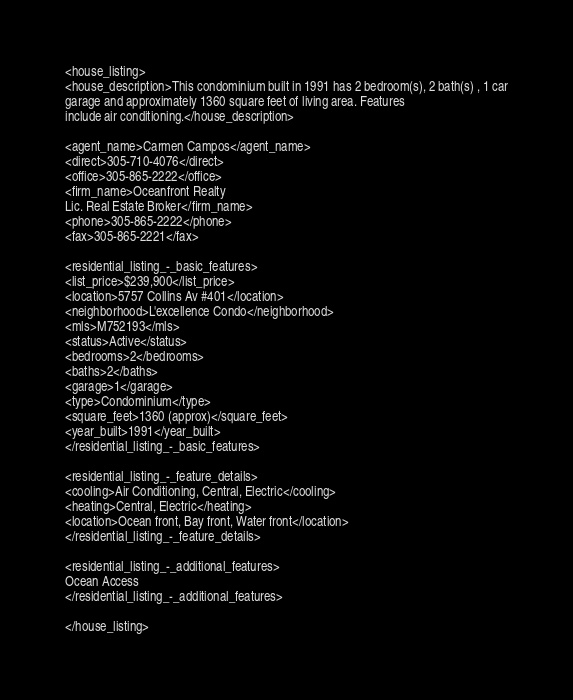<code> <loc_0><loc_0><loc_500><loc_500><_XML_><house_listing>
<house_description>This condominium built in 1991 has 2 bedroom(s), 2 bath(s) , 1 car
garage and approximately 1360 square feet of living area. Features
include air conditioning.</house_description>

<agent_name>Carmen Campos</agent_name>
<direct>305-710-4076</direct>
<office>305-865-2222</office>
<firm_name>Oceanfront Realty
Lic. Real Estate Broker</firm_name>
<phone>305-865-2222</phone>
<fax>305-865-2221</fax>

<residential_listing_-_basic_features>
<list_price>$239,900</list_price>
<location>5757 Collins Av #401</location>
<neighborhood>L'excellence Condo</neighborhood>
<mls>M752193</mls>
<status>Active</status>
<bedrooms>2</bedrooms>
<baths>2</baths>
<garage>1</garage>
<type>Condominium</type>
<square_feet>1360 (approx)</square_feet>
<year_built>1991</year_built>
</residential_listing_-_basic_features>

<residential_listing_-_feature_details>
<cooling>Air Conditioning, Central, Electric</cooling>
<heating>Central, Electric</heating>
<location>Ocean front, Bay front, Water front</location>
</residential_listing_-_feature_details>

<residential_listing_-_additional_features>
Ocean Access
</residential_listing_-_additional_features>

</house_listing>



</code> 